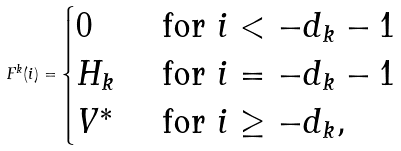<formula> <loc_0><loc_0><loc_500><loc_500>F ^ { k } ( i ) = \begin{cases} 0 & \text { for } i < - d _ { k } - 1 \\ H _ { k } & \text { for } i = - d _ { k } - 1 \\ V ^ { * } & \text { for } i \geq - d _ { k } , \end{cases}</formula> 